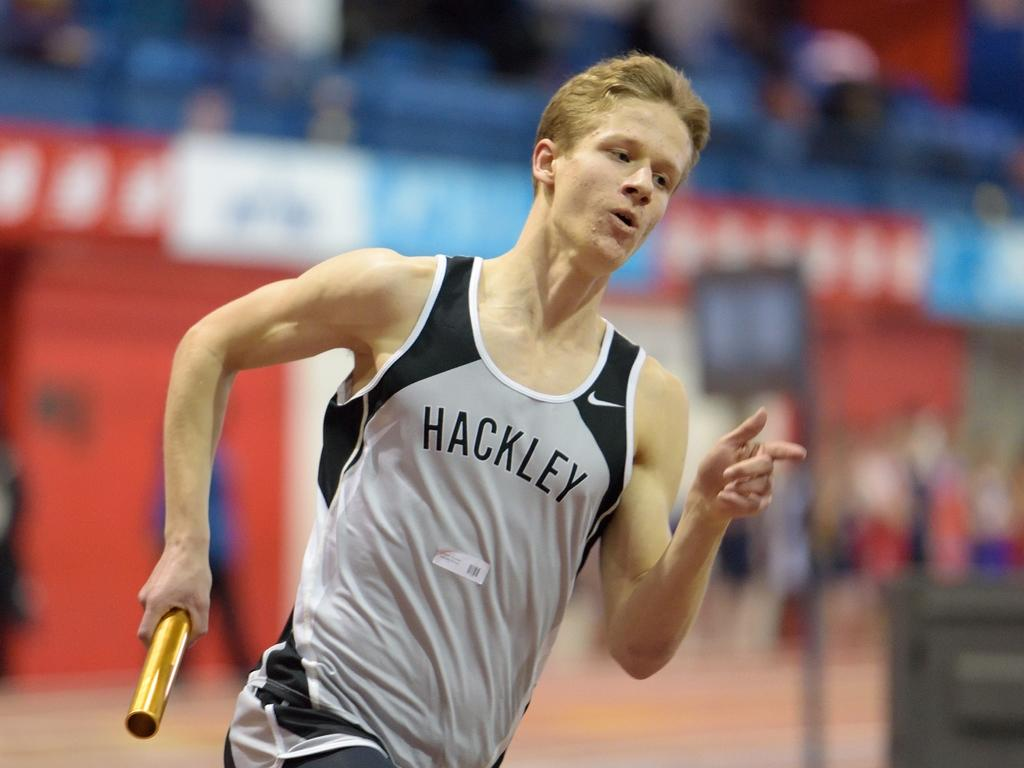<image>
Share a concise interpretation of the image provided. The relay runner from Hackley has the baton in his hand. 